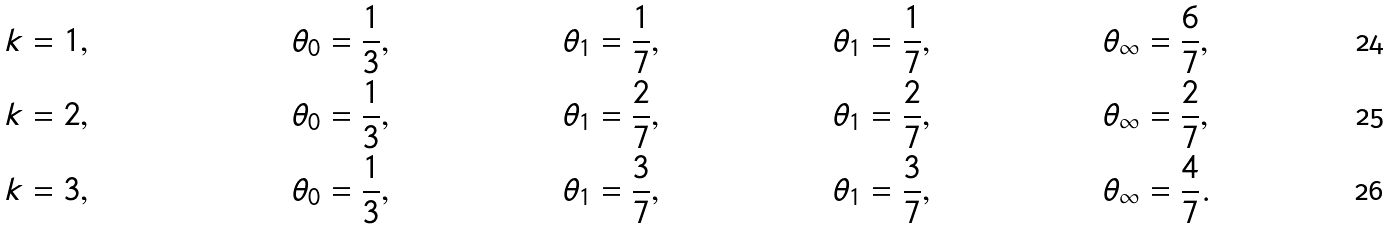<formula> <loc_0><loc_0><loc_500><loc_500>k & = 1 , \quad & \theta _ { 0 } & = \frac { 1 } { 3 } , & \theta _ { 1 } & = \frac { 1 } { 7 } , & \theta _ { 1 } & = \frac { 1 } { 7 } , & \theta _ { \infty } & = \frac { 6 } { 7 } , \\ k & = 2 , \quad & \theta _ { 0 } & = \frac { 1 } { 3 } , & \theta _ { 1 } & = \frac { 2 } { 7 } , & \theta _ { 1 } & = \frac { 2 } { 7 } , & \theta _ { \infty } & = \frac { 2 } { 7 } , \\ k & = 3 , \quad & \theta _ { 0 } & = \frac { 1 } { 3 } , & \theta _ { 1 } & = \frac { 3 } { 7 } , & \theta _ { 1 } & = \frac { 3 } { 7 } , & \theta _ { \infty } & = \frac { 4 } { 7 } .</formula> 